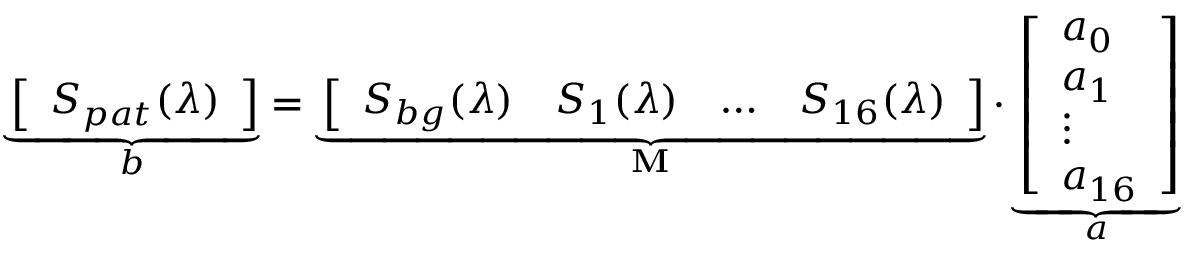<formula> <loc_0><loc_0><loc_500><loc_500>\underbrace { \left [ \begin{array} { l } { S _ { p a t } ( \lambda ) } \end{array} \right ] } _ { b } = \underbrace { \left [ \begin{array} { l l l l } { S _ { b g } ( \lambda ) } & { S _ { 1 } ( \lambda ) } & { \dots } & { S _ { 1 6 } ( \lambda ) } \end{array} \right ] } _ { M } \cdot \underbrace { \left [ \begin{array} { l } { a _ { 0 } } \\ { a _ { 1 } } \\ { \vdots } \\ { a _ { 1 6 } } \end{array} \right ] } _ { a }</formula> 